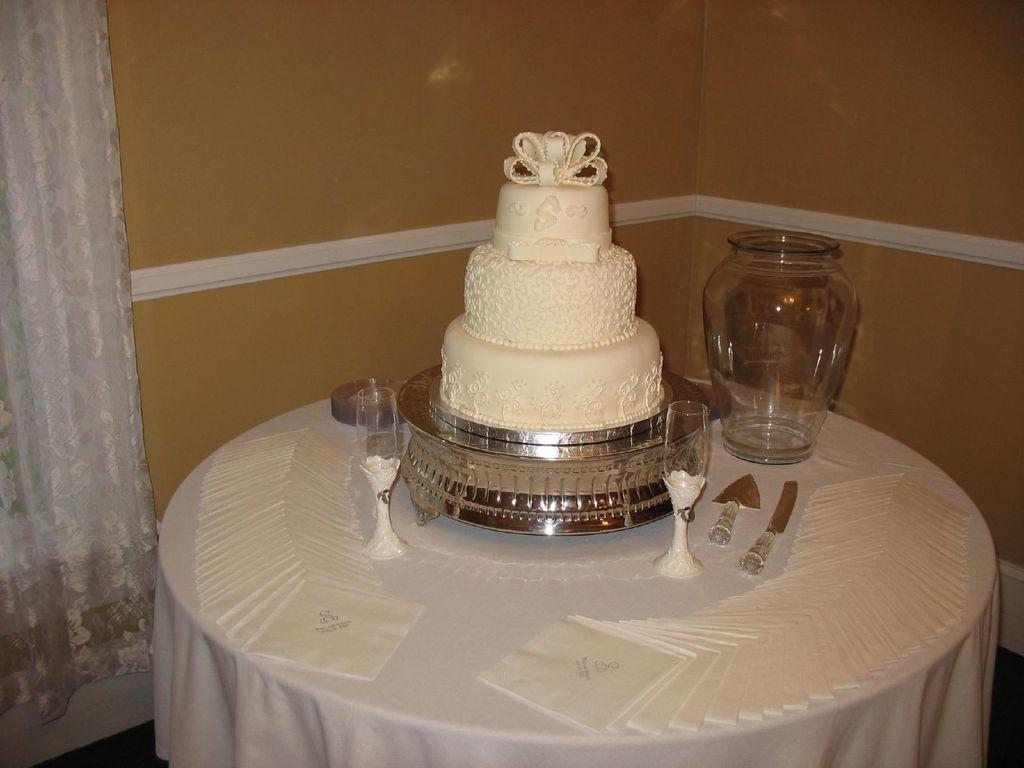Describe this image in one or two sentences. In this image, we can see a table in front of the wall covered with a cloth. This table contains glasses, jar and cake. 